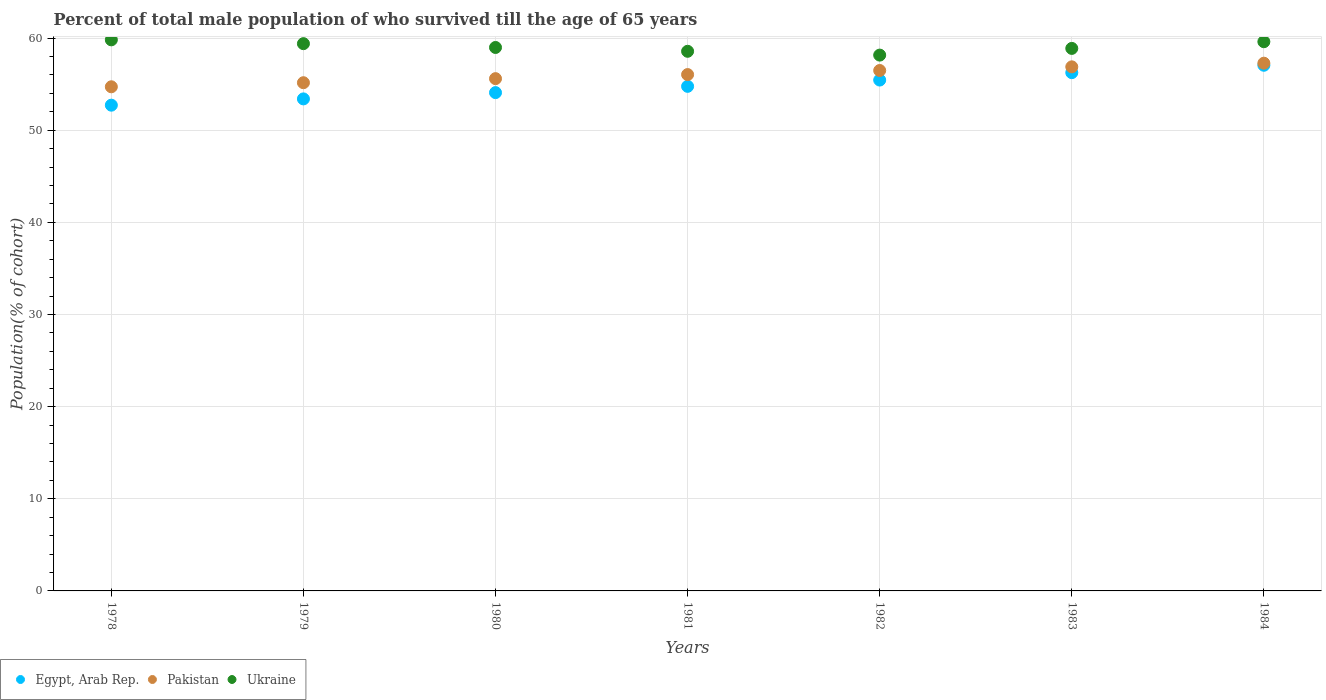How many different coloured dotlines are there?
Your response must be concise. 3. What is the percentage of total male population who survived till the age of 65 years in Ukraine in 1979?
Offer a very short reply. 59.39. Across all years, what is the maximum percentage of total male population who survived till the age of 65 years in Ukraine?
Your answer should be very brief. 59.8. Across all years, what is the minimum percentage of total male population who survived till the age of 65 years in Ukraine?
Your response must be concise. 58.14. In which year was the percentage of total male population who survived till the age of 65 years in Ukraine minimum?
Your answer should be very brief. 1982. What is the total percentage of total male population who survived till the age of 65 years in Pakistan in the graph?
Make the answer very short. 392.09. What is the difference between the percentage of total male population who survived till the age of 65 years in Ukraine in 1980 and that in 1982?
Your response must be concise. 0.83. What is the difference between the percentage of total male population who survived till the age of 65 years in Ukraine in 1983 and the percentage of total male population who survived till the age of 65 years in Pakistan in 1981?
Ensure brevity in your answer.  2.84. What is the average percentage of total male population who survived till the age of 65 years in Pakistan per year?
Your answer should be compact. 56.01. In the year 1978, what is the difference between the percentage of total male population who survived till the age of 65 years in Egypt, Arab Rep. and percentage of total male population who survived till the age of 65 years in Ukraine?
Give a very brief answer. -7.09. What is the ratio of the percentage of total male population who survived till the age of 65 years in Ukraine in 1978 to that in 1984?
Your answer should be compact. 1. Is the difference between the percentage of total male population who survived till the age of 65 years in Egypt, Arab Rep. in 1978 and 1983 greater than the difference between the percentage of total male population who survived till the age of 65 years in Ukraine in 1978 and 1983?
Your answer should be compact. No. What is the difference between the highest and the second highest percentage of total male population who survived till the age of 65 years in Pakistan?
Give a very brief answer. 0.4. What is the difference between the highest and the lowest percentage of total male population who survived till the age of 65 years in Pakistan?
Keep it short and to the point. 2.56. In how many years, is the percentage of total male population who survived till the age of 65 years in Egypt, Arab Rep. greater than the average percentage of total male population who survived till the age of 65 years in Egypt, Arab Rep. taken over all years?
Your answer should be compact. 3. Is the sum of the percentage of total male population who survived till the age of 65 years in Egypt, Arab Rep. in 1981 and 1984 greater than the maximum percentage of total male population who survived till the age of 65 years in Ukraine across all years?
Offer a very short reply. Yes. How many years are there in the graph?
Offer a very short reply. 7. Does the graph contain grids?
Ensure brevity in your answer.  Yes. How many legend labels are there?
Your answer should be very brief. 3. How are the legend labels stacked?
Provide a succinct answer. Horizontal. What is the title of the graph?
Provide a succinct answer. Percent of total male population of who survived till the age of 65 years. Does "Madagascar" appear as one of the legend labels in the graph?
Provide a short and direct response. No. What is the label or title of the X-axis?
Offer a very short reply. Years. What is the label or title of the Y-axis?
Your answer should be compact. Population(% of cohort). What is the Population(% of cohort) in Egypt, Arab Rep. in 1978?
Offer a terse response. 52.71. What is the Population(% of cohort) of Pakistan in 1978?
Give a very brief answer. 54.71. What is the Population(% of cohort) in Ukraine in 1978?
Your answer should be compact. 59.8. What is the Population(% of cohort) of Egypt, Arab Rep. in 1979?
Offer a terse response. 53.39. What is the Population(% of cohort) in Pakistan in 1979?
Offer a terse response. 55.15. What is the Population(% of cohort) in Ukraine in 1979?
Offer a terse response. 59.39. What is the Population(% of cohort) in Egypt, Arab Rep. in 1980?
Your answer should be very brief. 54.07. What is the Population(% of cohort) in Pakistan in 1980?
Make the answer very short. 55.59. What is the Population(% of cohort) in Ukraine in 1980?
Make the answer very short. 58.97. What is the Population(% of cohort) in Egypt, Arab Rep. in 1981?
Offer a terse response. 54.76. What is the Population(% of cohort) in Pakistan in 1981?
Provide a short and direct response. 56.03. What is the Population(% of cohort) in Ukraine in 1981?
Offer a very short reply. 58.56. What is the Population(% of cohort) of Egypt, Arab Rep. in 1982?
Provide a short and direct response. 55.44. What is the Population(% of cohort) in Pakistan in 1982?
Offer a terse response. 56.47. What is the Population(% of cohort) of Ukraine in 1982?
Provide a succinct answer. 58.14. What is the Population(% of cohort) of Egypt, Arab Rep. in 1983?
Give a very brief answer. 56.24. What is the Population(% of cohort) of Pakistan in 1983?
Keep it short and to the point. 56.87. What is the Population(% of cohort) in Ukraine in 1983?
Make the answer very short. 58.87. What is the Population(% of cohort) of Egypt, Arab Rep. in 1984?
Offer a very short reply. 57.04. What is the Population(% of cohort) of Pakistan in 1984?
Offer a very short reply. 57.27. What is the Population(% of cohort) of Ukraine in 1984?
Ensure brevity in your answer.  59.6. Across all years, what is the maximum Population(% of cohort) in Egypt, Arab Rep.?
Ensure brevity in your answer.  57.04. Across all years, what is the maximum Population(% of cohort) in Pakistan?
Your answer should be very brief. 57.27. Across all years, what is the maximum Population(% of cohort) in Ukraine?
Provide a succinct answer. 59.8. Across all years, what is the minimum Population(% of cohort) in Egypt, Arab Rep.?
Your answer should be compact. 52.71. Across all years, what is the minimum Population(% of cohort) of Pakistan?
Offer a very short reply. 54.71. Across all years, what is the minimum Population(% of cohort) of Ukraine?
Offer a very short reply. 58.14. What is the total Population(% of cohort) in Egypt, Arab Rep. in the graph?
Offer a very short reply. 383.65. What is the total Population(% of cohort) of Pakistan in the graph?
Provide a short and direct response. 392.09. What is the total Population(% of cohort) in Ukraine in the graph?
Keep it short and to the point. 413.33. What is the difference between the Population(% of cohort) of Egypt, Arab Rep. in 1978 and that in 1979?
Offer a terse response. -0.68. What is the difference between the Population(% of cohort) in Pakistan in 1978 and that in 1979?
Ensure brevity in your answer.  -0.44. What is the difference between the Population(% of cohort) in Ukraine in 1978 and that in 1979?
Keep it short and to the point. 0.41. What is the difference between the Population(% of cohort) in Egypt, Arab Rep. in 1978 and that in 1980?
Provide a succinct answer. -1.36. What is the difference between the Population(% of cohort) of Pakistan in 1978 and that in 1980?
Your answer should be compact. -0.88. What is the difference between the Population(% of cohort) of Ukraine in 1978 and that in 1980?
Your answer should be compact. 0.83. What is the difference between the Population(% of cohort) of Egypt, Arab Rep. in 1978 and that in 1981?
Give a very brief answer. -2.04. What is the difference between the Population(% of cohort) in Pakistan in 1978 and that in 1981?
Offer a terse response. -1.33. What is the difference between the Population(% of cohort) in Ukraine in 1978 and that in 1981?
Provide a succinct answer. 1.24. What is the difference between the Population(% of cohort) in Egypt, Arab Rep. in 1978 and that in 1982?
Your answer should be very brief. -2.73. What is the difference between the Population(% of cohort) in Pakistan in 1978 and that in 1982?
Ensure brevity in your answer.  -1.77. What is the difference between the Population(% of cohort) in Ukraine in 1978 and that in 1982?
Your answer should be compact. 1.66. What is the difference between the Population(% of cohort) of Egypt, Arab Rep. in 1978 and that in 1983?
Ensure brevity in your answer.  -3.53. What is the difference between the Population(% of cohort) of Pakistan in 1978 and that in 1983?
Your answer should be compact. -2.16. What is the difference between the Population(% of cohort) of Ukraine in 1978 and that in 1983?
Provide a short and direct response. 0.93. What is the difference between the Population(% of cohort) in Egypt, Arab Rep. in 1978 and that in 1984?
Give a very brief answer. -4.33. What is the difference between the Population(% of cohort) of Pakistan in 1978 and that in 1984?
Ensure brevity in your answer.  -2.56. What is the difference between the Population(% of cohort) of Ukraine in 1978 and that in 1984?
Offer a terse response. 0.2. What is the difference between the Population(% of cohort) of Egypt, Arab Rep. in 1979 and that in 1980?
Keep it short and to the point. -0.68. What is the difference between the Population(% of cohort) in Pakistan in 1979 and that in 1980?
Your answer should be compact. -0.44. What is the difference between the Population(% of cohort) of Ukraine in 1979 and that in 1980?
Provide a succinct answer. 0.41. What is the difference between the Population(% of cohort) of Egypt, Arab Rep. in 1979 and that in 1981?
Make the answer very short. -1.36. What is the difference between the Population(% of cohort) of Pakistan in 1979 and that in 1981?
Keep it short and to the point. -0.88. What is the difference between the Population(% of cohort) of Ukraine in 1979 and that in 1981?
Your response must be concise. 0.83. What is the difference between the Population(% of cohort) in Egypt, Arab Rep. in 1979 and that in 1982?
Your answer should be compact. -2.04. What is the difference between the Population(% of cohort) in Pakistan in 1979 and that in 1982?
Make the answer very short. -1.33. What is the difference between the Population(% of cohort) of Ukraine in 1979 and that in 1982?
Keep it short and to the point. 1.24. What is the difference between the Population(% of cohort) in Egypt, Arab Rep. in 1979 and that in 1983?
Provide a succinct answer. -2.85. What is the difference between the Population(% of cohort) of Pakistan in 1979 and that in 1983?
Your response must be concise. -1.72. What is the difference between the Population(% of cohort) in Ukraine in 1979 and that in 1983?
Offer a very short reply. 0.52. What is the difference between the Population(% of cohort) in Egypt, Arab Rep. in 1979 and that in 1984?
Offer a very short reply. -3.65. What is the difference between the Population(% of cohort) of Pakistan in 1979 and that in 1984?
Make the answer very short. -2.12. What is the difference between the Population(% of cohort) in Ukraine in 1979 and that in 1984?
Your response must be concise. -0.21. What is the difference between the Population(% of cohort) in Egypt, Arab Rep. in 1980 and that in 1981?
Your response must be concise. -0.68. What is the difference between the Population(% of cohort) of Pakistan in 1980 and that in 1981?
Your answer should be compact. -0.44. What is the difference between the Population(% of cohort) of Ukraine in 1980 and that in 1981?
Your response must be concise. 0.41. What is the difference between the Population(% of cohort) in Egypt, Arab Rep. in 1980 and that in 1982?
Ensure brevity in your answer.  -1.36. What is the difference between the Population(% of cohort) in Pakistan in 1980 and that in 1982?
Your answer should be compact. -0.88. What is the difference between the Population(% of cohort) in Ukraine in 1980 and that in 1982?
Give a very brief answer. 0.83. What is the difference between the Population(% of cohort) in Egypt, Arab Rep. in 1980 and that in 1983?
Provide a succinct answer. -2.17. What is the difference between the Population(% of cohort) in Pakistan in 1980 and that in 1983?
Your answer should be compact. -1.28. What is the difference between the Population(% of cohort) in Ukraine in 1980 and that in 1983?
Ensure brevity in your answer.  0.1. What is the difference between the Population(% of cohort) in Egypt, Arab Rep. in 1980 and that in 1984?
Provide a succinct answer. -2.97. What is the difference between the Population(% of cohort) of Pakistan in 1980 and that in 1984?
Ensure brevity in your answer.  -1.68. What is the difference between the Population(% of cohort) of Ukraine in 1980 and that in 1984?
Provide a succinct answer. -0.63. What is the difference between the Population(% of cohort) of Egypt, Arab Rep. in 1981 and that in 1982?
Make the answer very short. -0.68. What is the difference between the Population(% of cohort) of Pakistan in 1981 and that in 1982?
Your answer should be very brief. -0.44. What is the difference between the Population(% of cohort) in Ukraine in 1981 and that in 1982?
Your answer should be compact. 0.41. What is the difference between the Population(% of cohort) of Egypt, Arab Rep. in 1981 and that in 1983?
Provide a succinct answer. -1.48. What is the difference between the Population(% of cohort) in Pakistan in 1981 and that in 1983?
Your answer should be very brief. -0.84. What is the difference between the Population(% of cohort) of Ukraine in 1981 and that in 1983?
Your answer should be compact. -0.31. What is the difference between the Population(% of cohort) in Egypt, Arab Rep. in 1981 and that in 1984?
Provide a succinct answer. -2.29. What is the difference between the Population(% of cohort) of Pakistan in 1981 and that in 1984?
Your answer should be very brief. -1.24. What is the difference between the Population(% of cohort) in Ukraine in 1981 and that in 1984?
Your answer should be compact. -1.04. What is the difference between the Population(% of cohort) of Egypt, Arab Rep. in 1982 and that in 1983?
Provide a succinct answer. -0.8. What is the difference between the Population(% of cohort) in Pakistan in 1982 and that in 1983?
Ensure brevity in your answer.  -0.4. What is the difference between the Population(% of cohort) in Ukraine in 1982 and that in 1983?
Offer a very short reply. -0.73. What is the difference between the Population(% of cohort) in Egypt, Arab Rep. in 1982 and that in 1984?
Keep it short and to the point. -1.61. What is the difference between the Population(% of cohort) in Pakistan in 1982 and that in 1984?
Make the answer very short. -0.79. What is the difference between the Population(% of cohort) of Ukraine in 1982 and that in 1984?
Offer a terse response. -1.45. What is the difference between the Population(% of cohort) of Egypt, Arab Rep. in 1983 and that in 1984?
Provide a succinct answer. -0.8. What is the difference between the Population(% of cohort) of Pakistan in 1983 and that in 1984?
Keep it short and to the point. -0.4. What is the difference between the Population(% of cohort) of Ukraine in 1983 and that in 1984?
Your answer should be very brief. -0.73. What is the difference between the Population(% of cohort) in Egypt, Arab Rep. in 1978 and the Population(% of cohort) in Pakistan in 1979?
Your answer should be very brief. -2.44. What is the difference between the Population(% of cohort) in Egypt, Arab Rep. in 1978 and the Population(% of cohort) in Ukraine in 1979?
Offer a terse response. -6.68. What is the difference between the Population(% of cohort) in Pakistan in 1978 and the Population(% of cohort) in Ukraine in 1979?
Offer a very short reply. -4.68. What is the difference between the Population(% of cohort) of Egypt, Arab Rep. in 1978 and the Population(% of cohort) of Pakistan in 1980?
Offer a terse response. -2.88. What is the difference between the Population(% of cohort) of Egypt, Arab Rep. in 1978 and the Population(% of cohort) of Ukraine in 1980?
Provide a succinct answer. -6.26. What is the difference between the Population(% of cohort) in Pakistan in 1978 and the Population(% of cohort) in Ukraine in 1980?
Your answer should be very brief. -4.27. What is the difference between the Population(% of cohort) in Egypt, Arab Rep. in 1978 and the Population(% of cohort) in Pakistan in 1981?
Your answer should be very brief. -3.32. What is the difference between the Population(% of cohort) of Egypt, Arab Rep. in 1978 and the Population(% of cohort) of Ukraine in 1981?
Ensure brevity in your answer.  -5.85. What is the difference between the Population(% of cohort) in Pakistan in 1978 and the Population(% of cohort) in Ukraine in 1981?
Your answer should be very brief. -3.85. What is the difference between the Population(% of cohort) in Egypt, Arab Rep. in 1978 and the Population(% of cohort) in Pakistan in 1982?
Your response must be concise. -3.76. What is the difference between the Population(% of cohort) in Egypt, Arab Rep. in 1978 and the Population(% of cohort) in Ukraine in 1982?
Give a very brief answer. -5.43. What is the difference between the Population(% of cohort) in Pakistan in 1978 and the Population(% of cohort) in Ukraine in 1982?
Ensure brevity in your answer.  -3.44. What is the difference between the Population(% of cohort) of Egypt, Arab Rep. in 1978 and the Population(% of cohort) of Pakistan in 1983?
Ensure brevity in your answer.  -4.16. What is the difference between the Population(% of cohort) of Egypt, Arab Rep. in 1978 and the Population(% of cohort) of Ukraine in 1983?
Offer a very short reply. -6.16. What is the difference between the Population(% of cohort) in Pakistan in 1978 and the Population(% of cohort) in Ukraine in 1983?
Offer a very short reply. -4.17. What is the difference between the Population(% of cohort) in Egypt, Arab Rep. in 1978 and the Population(% of cohort) in Pakistan in 1984?
Ensure brevity in your answer.  -4.56. What is the difference between the Population(% of cohort) of Egypt, Arab Rep. in 1978 and the Population(% of cohort) of Ukraine in 1984?
Your answer should be compact. -6.89. What is the difference between the Population(% of cohort) of Pakistan in 1978 and the Population(% of cohort) of Ukraine in 1984?
Offer a very short reply. -4.89. What is the difference between the Population(% of cohort) of Egypt, Arab Rep. in 1979 and the Population(% of cohort) of Pakistan in 1980?
Give a very brief answer. -2.2. What is the difference between the Population(% of cohort) of Egypt, Arab Rep. in 1979 and the Population(% of cohort) of Ukraine in 1980?
Your response must be concise. -5.58. What is the difference between the Population(% of cohort) in Pakistan in 1979 and the Population(% of cohort) in Ukraine in 1980?
Keep it short and to the point. -3.82. What is the difference between the Population(% of cohort) in Egypt, Arab Rep. in 1979 and the Population(% of cohort) in Pakistan in 1981?
Provide a short and direct response. -2.64. What is the difference between the Population(% of cohort) in Egypt, Arab Rep. in 1979 and the Population(% of cohort) in Ukraine in 1981?
Offer a very short reply. -5.17. What is the difference between the Population(% of cohort) of Pakistan in 1979 and the Population(% of cohort) of Ukraine in 1981?
Offer a terse response. -3.41. What is the difference between the Population(% of cohort) of Egypt, Arab Rep. in 1979 and the Population(% of cohort) of Pakistan in 1982?
Keep it short and to the point. -3.08. What is the difference between the Population(% of cohort) of Egypt, Arab Rep. in 1979 and the Population(% of cohort) of Ukraine in 1982?
Give a very brief answer. -4.75. What is the difference between the Population(% of cohort) of Pakistan in 1979 and the Population(% of cohort) of Ukraine in 1982?
Make the answer very short. -3. What is the difference between the Population(% of cohort) in Egypt, Arab Rep. in 1979 and the Population(% of cohort) in Pakistan in 1983?
Ensure brevity in your answer.  -3.48. What is the difference between the Population(% of cohort) in Egypt, Arab Rep. in 1979 and the Population(% of cohort) in Ukraine in 1983?
Keep it short and to the point. -5.48. What is the difference between the Population(% of cohort) in Pakistan in 1979 and the Population(% of cohort) in Ukraine in 1983?
Give a very brief answer. -3.72. What is the difference between the Population(% of cohort) in Egypt, Arab Rep. in 1979 and the Population(% of cohort) in Pakistan in 1984?
Provide a short and direct response. -3.88. What is the difference between the Population(% of cohort) of Egypt, Arab Rep. in 1979 and the Population(% of cohort) of Ukraine in 1984?
Offer a very short reply. -6.21. What is the difference between the Population(% of cohort) in Pakistan in 1979 and the Population(% of cohort) in Ukraine in 1984?
Give a very brief answer. -4.45. What is the difference between the Population(% of cohort) in Egypt, Arab Rep. in 1980 and the Population(% of cohort) in Pakistan in 1981?
Your response must be concise. -1.96. What is the difference between the Population(% of cohort) of Egypt, Arab Rep. in 1980 and the Population(% of cohort) of Ukraine in 1981?
Keep it short and to the point. -4.48. What is the difference between the Population(% of cohort) of Pakistan in 1980 and the Population(% of cohort) of Ukraine in 1981?
Offer a very short reply. -2.97. What is the difference between the Population(% of cohort) in Egypt, Arab Rep. in 1980 and the Population(% of cohort) in Pakistan in 1982?
Offer a very short reply. -2.4. What is the difference between the Population(% of cohort) in Egypt, Arab Rep. in 1980 and the Population(% of cohort) in Ukraine in 1982?
Offer a terse response. -4.07. What is the difference between the Population(% of cohort) in Pakistan in 1980 and the Population(% of cohort) in Ukraine in 1982?
Provide a short and direct response. -2.55. What is the difference between the Population(% of cohort) in Egypt, Arab Rep. in 1980 and the Population(% of cohort) in Pakistan in 1983?
Your response must be concise. -2.8. What is the difference between the Population(% of cohort) in Egypt, Arab Rep. in 1980 and the Population(% of cohort) in Ukraine in 1983?
Give a very brief answer. -4.8. What is the difference between the Population(% of cohort) in Pakistan in 1980 and the Population(% of cohort) in Ukraine in 1983?
Ensure brevity in your answer.  -3.28. What is the difference between the Population(% of cohort) of Egypt, Arab Rep. in 1980 and the Population(% of cohort) of Pakistan in 1984?
Ensure brevity in your answer.  -3.19. What is the difference between the Population(% of cohort) in Egypt, Arab Rep. in 1980 and the Population(% of cohort) in Ukraine in 1984?
Offer a very short reply. -5.52. What is the difference between the Population(% of cohort) of Pakistan in 1980 and the Population(% of cohort) of Ukraine in 1984?
Provide a succinct answer. -4.01. What is the difference between the Population(% of cohort) of Egypt, Arab Rep. in 1981 and the Population(% of cohort) of Pakistan in 1982?
Make the answer very short. -1.72. What is the difference between the Population(% of cohort) in Egypt, Arab Rep. in 1981 and the Population(% of cohort) in Ukraine in 1982?
Offer a terse response. -3.39. What is the difference between the Population(% of cohort) of Pakistan in 1981 and the Population(% of cohort) of Ukraine in 1982?
Keep it short and to the point. -2.11. What is the difference between the Population(% of cohort) in Egypt, Arab Rep. in 1981 and the Population(% of cohort) in Pakistan in 1983?
Your answer should be very brief. -2.12. What is the difference between the Population(% of cohort) in Egypt, Arab Rep. in 1981 and the Population(% of cohort) in Ukraine in 1983?
Your answer should be very brief. -4.12. What is the difference between the Population(% of cohort) of Pakistan in 1981 and the Population(% of cohort) of Ukraine in 1983?
Your response must be concise. -2.84. What is the difference between the Population(% of cohort) in Egypt, Arab Rep. in 1981 and the Population(% of cohort) in Pakistan in 1984?
Make the answer very short. -2.51. What is the difference between the Population(% of cohort) in Egypt, Arab Rep. in 1981 and the Population(% of cohort) in Ukraine in 1984?
Make the answer very short. -4.84. What is the difference between the Population(% of cohort) of Pakistan in 1981 and the Population(% of cohort) of Ukraine in 1984?
Offer a terse response. -3.57. What is the difference between the Population(% of cohort) in Egypt, Arab Rep. in 1982 and the Population(% of cohort) in Pakistan in 1983?
Offer a terse response. -1.43. What is the difference between the Population(% of cohort) of Egypt, Arab Rep. in 1982 and the Population(% of cohort) of Ukraine in 1983?
Make the answer very short. -3.43. What is the difference between the Population(% of cohort) of Pakistan in 1982 and the Population(% of cohort) of Ukraine in 1983?
Offer a very short reply. -2.4. What is the difference between the Population(% of cohort) in Egypt, Arab Rep. in 1982 and the Population(% of cohort) in Pakistan in 1984?
Offer a very short reply. -1.83. What is the difference between the Population(% of cohort) in Egypt, Arab Rep. in 1982 and the Population(% of cohort) in Ukraine in 1984?
Ensure brevity in your answer.  -4.16. What is the difference between the Population(% of cohort) of Pakistan in 1982 and the Population(% of cohort) of Ukraine in 1984?
Offer a very short reply. -3.12. What is the difference between the Population(% of cohort) of Egypt, Arab Rep. in 1983 and the Population(% of cohort) of Pakistan in 1984?
Make the answer very short. -1.03. What is the difference between the Population(% of cohort) of Egypt, Arab Rep. in 1983 and the Population(% of cohort) of Ukraine in 1984?
Provide a succinct answer. -3.36. What is the difference between the Population(% of cohort) of Pakistan in 1983 and the Population(% of cohort) of Ukraine in 1984?
Ensure brevity in your answer.  -2.73. What is the average Population(% of cohort) in Egypt, Arab Rep. per year?
Offer a very short reply. 54.81. What is the average Population(% of cohort) of Pakistan per year?
Provide a short and direct response. 56.01. What is the average Population(% of cohort) in Ukraine per year?
Give a very brief answer. 59.05. In the year 1978, what is the difference between the Population(% of cohort) in Egypt, Arab Rep. and Population(% of cohort) in Pakistan?
Provide a short and direct response. -2. In the year 1978, what is the difference between the Population(% of cohort) of Egypt, Arab Rep. and Population(% of cohort) of Ukraine?
Give a very brief answer. -7.09. In the year 1978, what is the difference between the Population(% of cohort) of Pakistan and Population(% of cohort) of Ukraine?
Offer a terse response. -5.09. In the year 1979, what is the difference between the Population(% of cohort) of Egypt, Arab Rep. and Population(% of cohort) of Pakistan?
Ensure brevity in your answer.  -1.76. In the year 1979, what is the difference between the Population(% of cohort) in Egypt, Arab Rep. and Population(% of cohort) in Ukraine?
Keep it short and to the point. -5.99. In the year 1979, what is the difference between the Population(% of cohort) in Pakistan and Population(% of cohort) in Ukraine?
Ensure brevity in your answer.  -4.24. In the year 1980, what is the difference between the Population(% of cohort) in Egypt, Arab Rep. and Population(% of cohort) in Pakistan?
Give a very brief answer. -1.52. In the year 1980, what is the difference between the Population(% of cohort) in Egypt, Arab Rep. and Population(% of cohort) in Ukraine?
Offer a very short reply. -4.9. In the year 1980, what is the difference between the Population(% of cohort) of Pakistan and Population(% of cohort) of Ukraine?
Offer a very short reply. -3.38. In the year 1981, what is the difference between the Population(% of cohort) in Egypt, Arab Rep. and Population(% of cohort) in Pakistan?
Offer a terse response. -1.28. In the year 1981, what is the difference between the Population(% of cohort) in Egypt, Arab Rep. and Population(% of cohort) in Ukraine?
Your answer should be compact. -3.8. In the year 1981, what is the difference between the Population(% of cohort) in Pakistan and Population(% of cohort) in Ukraine?
Offer a very short reply. -2.53. In the year 1982, what is the difference between the Population(% of cohort) of Egypt, Arab Rep. and Population(% of cohort) of Pakistan?
Provide a succinct answer. -1.04. In the year 1982, what is the difference between the Population(% of cohort) in Egypt, Arab Rep. and Population(% of cohort) in Ukraine?
Keep it short and to the point. -2.71. In the year 1982, what is the difference between the Population(% of cohort) of Pakistan and Population(% of cohort) of Ukraine?
Provide a short and direct response. -1.67. In the year 1983, what is the difference between the Population(% of cohort) of Egypt, Arab Rep. and Population(% of cohort) of Pakistan?
Provide a succinct answer. -0.63. In the year 1983, what is the difference between the Population(% of cohort) in Egypt, Arab Rep. and Population(% of cohort) in Ukraine?
Your answer should be compact. -2.63. In the year 1983, what is the difference between the Population(% of cohort) in Pakistan and Population(% of cohort) in Ukraine?
Your answer should be very brief. -2. In the year 1984, what is the difference between the Population(% of cohort) of Egypt, Arab Rep. and Population(% of cohort) of Pakistan?
Your response must be concise. -0.23. In the year 1984, what is the difference between the Population(% of cohort) of Egypt, Arab Rep. and Population(% of cohort) of Ukraine?
Make the answer very short. -2.56. In the year 1984, what is the difference between the Population(% of cohort) of Pakistan and Population(% of cohort) of Ukraine?
Provide a succinct answer. -2.33. What is the ratio of the Population(% of cohort) in Egypt, Arab Rep. in 1978 to that in 1979?
Your answer should be very brief. 0.99. What is the ratio of the Population(% of cohort) in Ukraine in 1978 to that in 1979?
Keep it short and to the point. 1.01. What is the ratio of the Population(% of cohort) of Egypt, Arab Rep. in 1978 to that in 1980?
Ensure brevity in your answer.  0.97. What is the ratio of the Population(% of cohort) in Pakistan in 1978 to that in 1980?
Provide a succinct answer. 0.98. What is the ratio of the Population(% of cohort) in Ukraine in 1978 to that in 1980?
Your answer should be very brief. 1.01. What is the ratio of the Population(% of cohort) of Egypt, Arab Rep. in 1978 to that in 1981?
Keep it short and to the point. 0.96. What is the ratio of the Population(% of cohort) in Pakistan in 1978 to that in 1981?
Your answer should be compact. 0.98. What is the ratio of the Population(% of cohort) in Ukraine in 1978 to that in 1981?
Your response must be concise. 1.02. What is the ratio of the Population(% of cohort) in Egypt, Arab Rep. in 1978 to that in 1982?
Your answer should be very brief. 0.95. What is the ratio of the Population(% of cohort) of Pakistan in 1978 to that in 1982?
Your answer should be very brief. 0.97. What is the ratio of the Population(% of cohort) of Ukraine in 1978 to that in 1982?
Your answer should be compact. 1.03. What is the ratio of the Population(% of cohort) of Egypt, Arab Rep. in 1978 to that in 1983?
Make the answer very short. 0.94. What is the ratio of the Population(% of cohort) in Pakistan in 1978 to that in 1983?
Make the answer very short. 0.96. What is the ratio of the Population(% of cohort) of Ukraine in 1978 to that in 1983?
Your response must be concise. 1.02. What is the ratio of the Population(% of cohort) of Egypt, Arab Rep. in 1978 to that in 1984?
Your response must be concise. 0.92. What is the ratio of the Population(% of cohort) in Pakistan in 1978 to that in 1984?
Your answer should be very brief. 0.96. What is the ratio of the Population(% of cohort) of Ukraine in 1978 to that in 1984?
Keep it short and to the point. 1. What is the ratio of the Population(% of cohort) in Egypt, Arab Rep. in 1979 to that in 1980?
Provide a short and direct response. 0.99. What is the ratio of the Population(% of cohort) of Pakistan in 1979 to that in 1980?
Offer a terse response. 0.99. What is the ratio of the Population(% of cohort) of Ukraine in 1979 to that in 1980?
Offer a terse response. 1.01. What is the ratio of the Population(% of cohort) of Egypt, Arab Rep. in 1979 to that in 1981?
Keep it short and to the point. 0.98. What is the ratio of the Population(% of cohort) of Pakistan in 1979 to that in 1981?
Your response must be concise. 0.98. What is the ratio of the Population(% of cohort) in Ukraine in 1979 to that in 1981?
Provide a succinct answer. 1.01. What is the ratio of the Population(% of cohort) in Egypt, Arab Rep. in 1979 to that in 1982?
Your response must be concise. 0.96. What is the ratio of the Population(% of cohort) of Pakistan in 1979 to that in 1982?
Provide a succinct answer. 0.98. What is the ratio of the Population(% of cohort) of Ukraine in 1979 to that in 1982?
Give a very brief answer. 1.02. What is the ratio of the Population(% of cohort) of Egypt, Arab Rep. in 1979 to that in 1983?
Provide a short and direct response. 0.95. What is the ratio of the Population(% of cohort) of Pakistan in 1979 to that in 1983?
Your answer should be compact. 0.97. What is the ratio of the Population(% of cohort) in Ukraine in 1979 to that in 1983?
Offer a terse response. 1.01. What is the ratio of the Population(% of cohort) in Egypt, Arab Rep. in 1979 to that in 1984?
Provide a succinct answer. 0.94. What is the ratio of the Population(% of cohort) in Ukraine in 1979 to that in 1984?
Keep it short and to the point. 1. What is the ratio of the Population(% of cohort) of Egypt, Arab Rep. in 1980 to that in 1981?
Your answer should be very brief. 0.99. What is the ratio of the Population(% of cohort) in Pakistan in 1980 to that in 1981?
Give a very brief answer. 0.99. What is the ratio of the Population(% of cohort) of Ukraine in 1980 to that in 1981?
Ensure brevity in your answer.  1.01. What is the ratio of the Population(% of cohort) in Egypt, Arab Rep. in 1980 to that in 1982?
Your answer should be compact. 0.98. What is the ratio of the Population(% of cohort) of Pakistan in 1980 to that in 1982?
Keep it short and to the point. 0.98. What is the ratio of the Population(% of cohort) of Ukraine in 1980 to that in 1982?
Keep it short and to the point. 1.01. What is the ratio of the Population(% of cohort) of Egypt, Arab Rep. in 1980 to that in 1983?
Give a very brief answer. 0.96. What is the ratio of the Population(% of cohort) of Pakistan in 1980 to that in 1983?
Provide a succinct answer. 0.98. What is the ratio of the Population(% of cohort) in Egypt, Arab Rep. in 1980 to that in 1984?
Ensure brevity in your answer.  0.95. What is the ratio of the Population(% of cohort) of Pakistan in 1980 to that in 1984?
Your response must be concise. 0.97. What is the ratio of the Population(% of cohort) of Ukraine in 1980 to that in 1984?
Make the answer very short. 0.99. What is the ratio of the Population(% of cohort) in Egypt, Arab Rep. in 1981 to that in 1982?
Provide a short and direct response. 0.99. What is the ratio of the Population(% of cohort) in Pakistan in 1981 to that in 1982?
Give a very brief answer. 0.99. What is the ratio of the Population(% of cohort) of Ukraine in 1981 to that in 1982?
Keep it short and to the point. 1.01. What is the ratio of the Population(% of cohort) in Egypt, Arab Rep. in 1981 to that in 1983?
Your answer should be compact. 0.97. What is the ratio of the Population(% of cohort) in Pakistan in 1981 to that in 1983?
Your answer should be compact. 0.99. What is the ratio of the Population(% of cohort) in Egypt, Arab Rep. in 1981 to that in 1984?
Provide a succinct answer. 0.96. What is the ratio of the Population(% of cohort) in Pakistan in 1981 to that in 1984?
Your response must be concise. 0.98. What is the ratio of the Population(% of cohort) in Ukraine in 1981 to that in 1984?
Provide a short and direct response. 0.98. What is the ratio of the Population(% of cohort) of Egypt, Arab Rep. in 1982 to that in 1983?
Your answer should be compact. 0.99. What is the ratio of the Population(% of cohort) of Ukraine in 1982 to that in 1983?
Provide a short and direct response. 0.99. What is the ratio of the Population(% of cohort) of Egypt, Arab Rep. in 1982 to that in 1984?
Keep it short and to the point. 0.97. What is the ratio of the Population(% of cohort) of Pakistan in 1982 to that in 1984?
Your answer should be very brief. 0.99. What is the ratio of the Population(% of cohort) in Ukraine in 1982 to that in 1984?
Offer a very short reply. 0.98. What is the ratio of the Population(% of cohort) in Egypt, Arab Rep. in 1983 to that in 1984?
Make the answer very short. 0.99. What is the ratio of the Population(% of cohort) in Pakistan in 1983 to that in 1984?
Provide a succinct answer. 0.99. What is the difference between the highest and the second highest Population(% of cohort) of Egypt, Arab Rep.?
Your answer should be compact. 0.8. What is the difference between the highest and the second highest Population(% of cohort) in Pakistan?
Ensure brevity in your answer.  0.4. What is the difference between the highest and the second highest Population(% of cohort) in Ukraine?
Your answer should be very brief. 0.2. What is the difference between the highest and the lowest Population(% of cohort) in Egypt, Arab Rep.?
Your response must be concise. 4.33. What is the difference between the highest and the lowest Population(% of cohort) of Pakistan?
Make the answer very short. 2.56. What is the difference between the highest and the lowest Population(% of cohort) in Ukraine?
Your answer should be very brief. 1.66. 